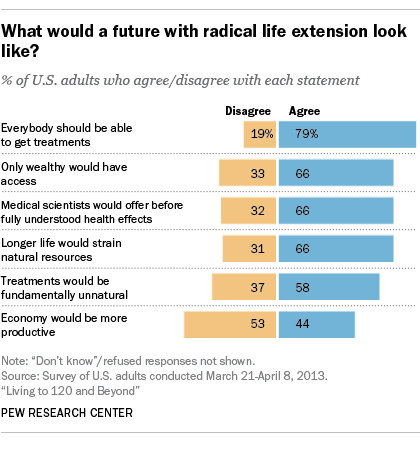Draw attention to some important aspects in this diagram. The most agreed upon opinion is more than the median disagreeing opinion, with a value of 46.5... The mode of the blue bars is 66. 